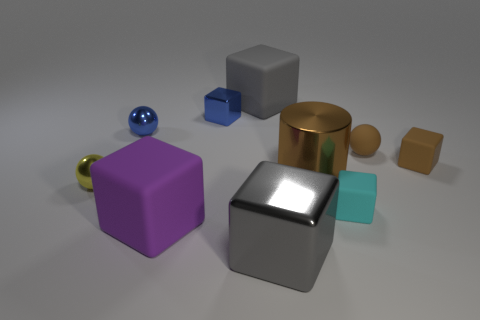Subtract 3 cubes. How many cubes are left? 3 Subtract all cyan cubes. How many cubes are left? 5 Subtract all brown matte cubes. How many cubes are left? 5 Subtract all purple blocks. Subtract all gray spheres. How many blocks are left? 5 Subtract all cylinders. How many objects are left? 9 Subtract all large metallic cylinders. Subtract all blue spheres. How many objects are left? 8 Add 7 large brown metal cylinders. How many large brown metal cylinders are left? 8 Add 5 large gray matte cubes. How many large gray matte cubes exist? 6 Subtract 1 blue cubes. How many objects are left? 9 